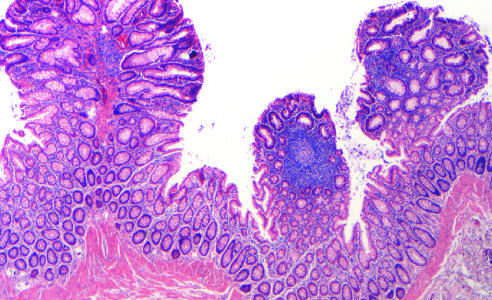re three tubular adenomas present in this single microscopic field?
Answer the question using a single word or phrase. Yes 